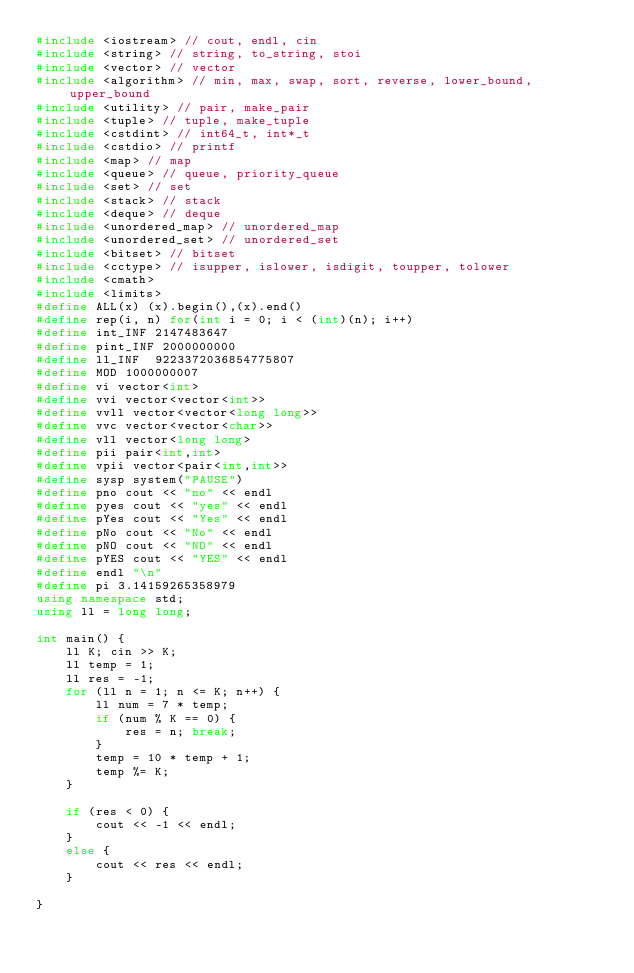Convert code to text. <code><loc_0><loc_0><loc_500><loc_500><_C++_>#include <iostream> // cout, endl, cin
#include <string> // string, to_string, stoi
#include <vector> // vector
#include <algorithm> // min, max, swap, sort, reverse, lower_bound, upper_bound
#include <utility> // pair, make_pair
#include <tuple> // tuple, make_tuple
#include <cstdint> // int64_t, int*_t
#include <cstdio> // printf
#include <map> // map
#include <queue> // queue, priority_queue
#include <set> // set
#include <stack> // stack
#include <deque> // deque
#include <unordered_map> // unordered_map
#include <unordered_set> // unordered_set
#include <bitset> // bitset
#include <cctype> // isupper, islower, isdigit, toupper, tolower
#include <cmath>
#include <limits>
#define ALL(x) (x).begin(),(x).end()
#define rep(i, n) for(int i = 0; i < (int)(n); i++)
#define int_INF 2147483647
#define pint_INF 2000000000
#define ll_INF 	9223372036854775807
#define MOD 1000000007
#define vi vector<int>
#define vvi vector<vector<int>>
#define vvll vector<vector<long long>>
#define vvc vector<vector<char>>
#define vll vector<long long>
#define pii pair<int,int>
#define vpii vector<pair<int,int>>
#define sysp system("PAUSE")
#define pno cout << "no" << endl
#define pyes cout << "yes" << endl
#define pYes cout << "Yes" << endl
#define pNo cout << "No" << endl
#define pNO cout << "NO" << endl
#define pYES cout << "YES" << endl
#define endl "\n"
#define pi 3.14159265358979
using namespace std;
using ll = long long;

int main() {
	ll K; cin >> K;
	ll temp = 1;
	ll res = -1;
	for (ll n = 1; n <= K; n++) {
		ll num = 7 * temp;
		if (num % K == 0) {
			res = n; break;
		}
		temp = 10 * temp + 1;
		temp %= K;
	}

	if (res < 0) {
		cout << -1 << endl;
	}
	else {
		cout << res << endl;
	}

}</code> 